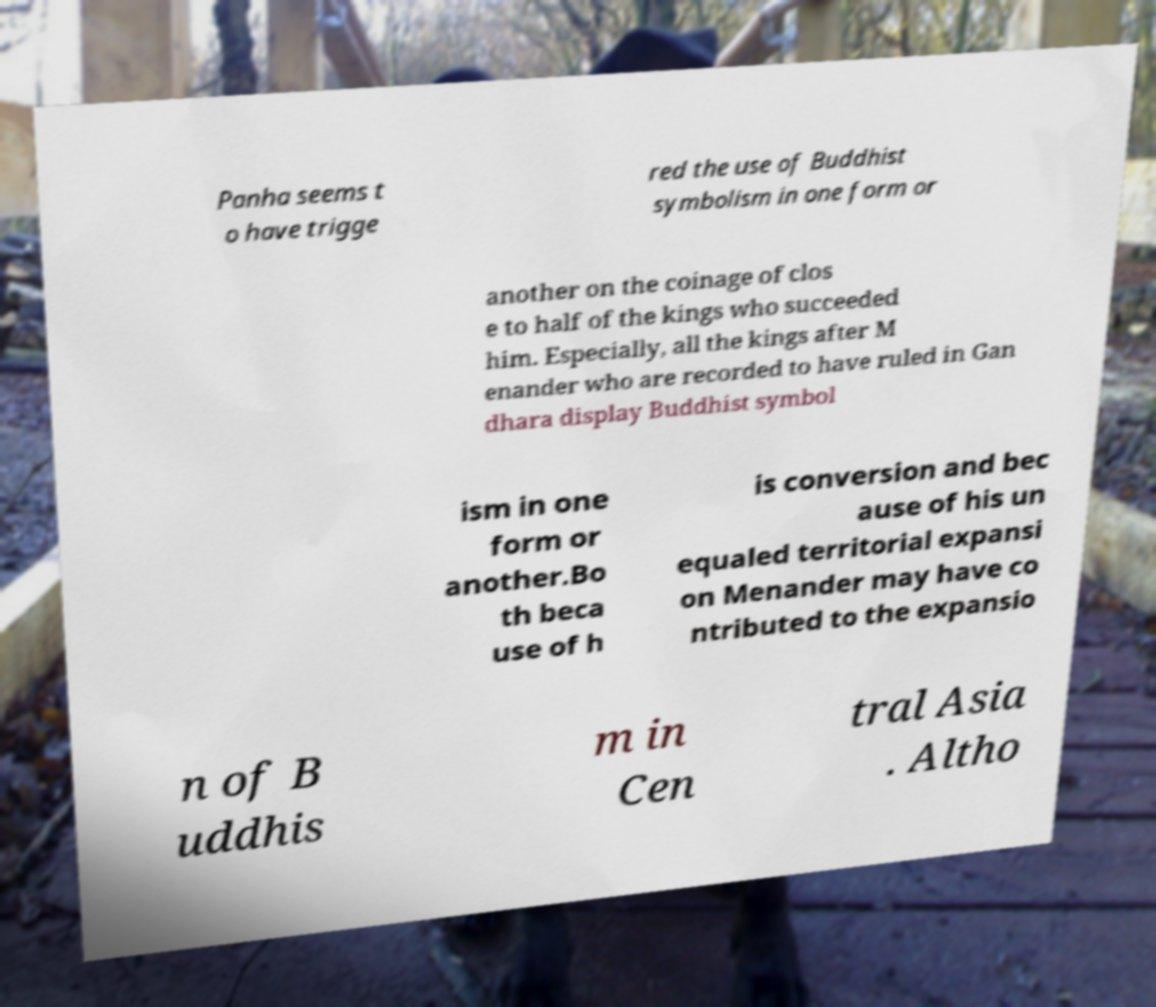Could you assist in decoding the text presented in this image and type it out clearly? Panha seems t o have trigge red the use of Buddhist symbolism in one form or another on the coinage of clos e to half of the kings who succeeded him. Especially, all the kings after M enander who are recorded to have ruled in Gan dhara display Buddhist symbol ism in one form or another.Bo th beca use of h is conversion and bec ause of his un equaled territorial expansi on Menander may have co ntributed to the expansio n of B uddhis m in Cen tral Asia . Altho 